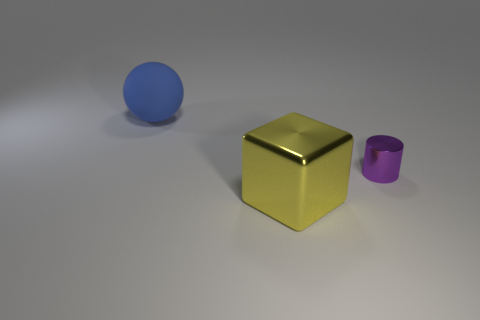Subtract all balls. How many objects are left? 2 Add 3 cyan cylinders. How many objects exist? 6 Subtract all tiny purple shiny cylinders. Subtract all tiny purple metallic things. How many objects are left? 1 Add 3 blue spheres. How many blue spheres are left? 4 Add 3 small brown metallic blocks. How many small brown metallic blocks exist? 3 Subtract 0 yellow cylinders. How many objects are left? 3 